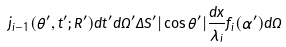<formula> <loc_0><loc_0><loc_500><loc_500>j _ { i - 1 } ( \theta ^ { \prime } , t ^ { \prime } ; R ^ { \prime } ) d t ^ { \prime } d \Omega ^ { \prime } \Delta S ^ { \prime } | \cos \theta ^ { \prime } | \frac { d x } { \lambda _ { i } } f _ { i } ( \alpha ^ { \prime } ) d \Omega</formula> 